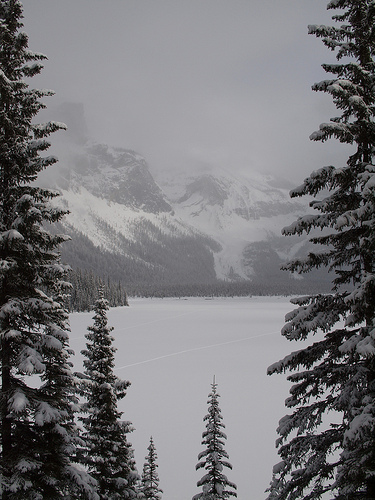<image>
Is the tree behind the mountains? No. The tree is not behind the mountains. From this viewpoint, the tree appears to be positioned elsewhere in the scene. 